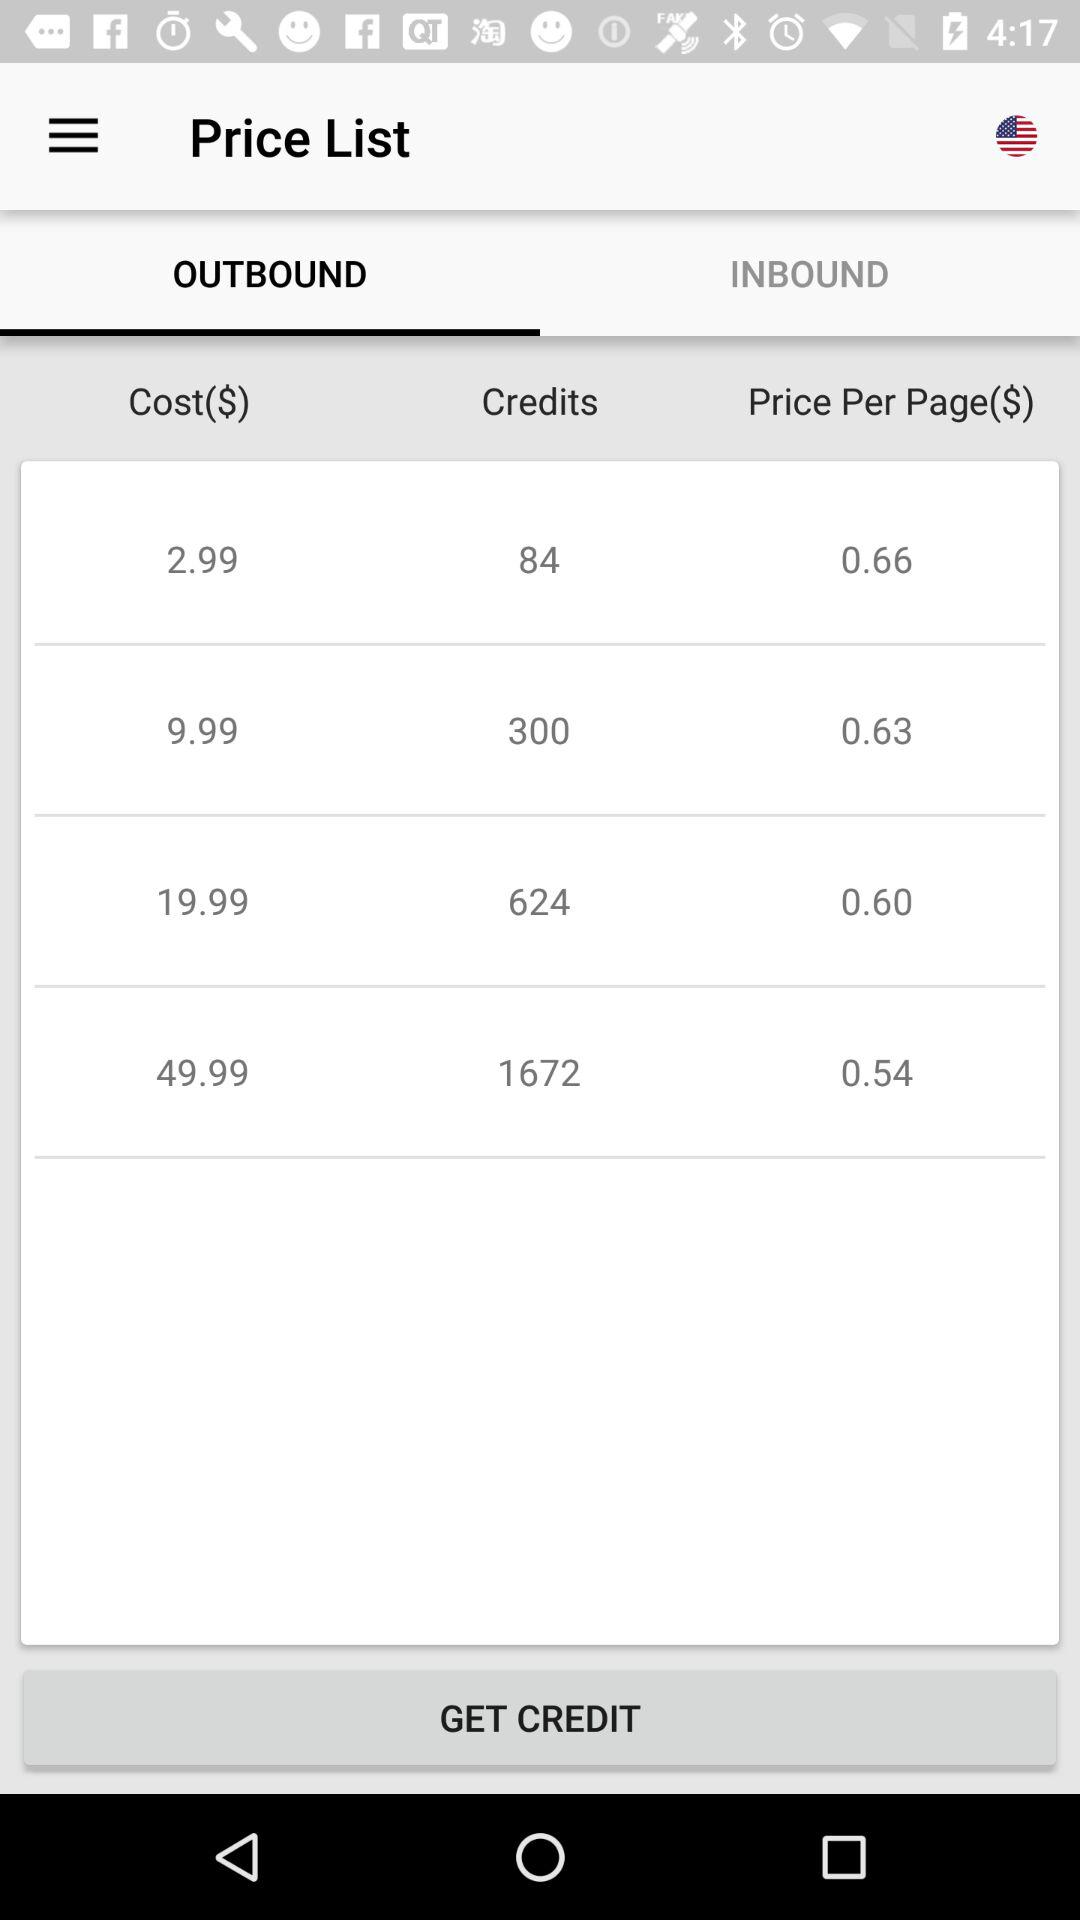What is the per-page price of 300 credits? The per-page price is 0.63. 